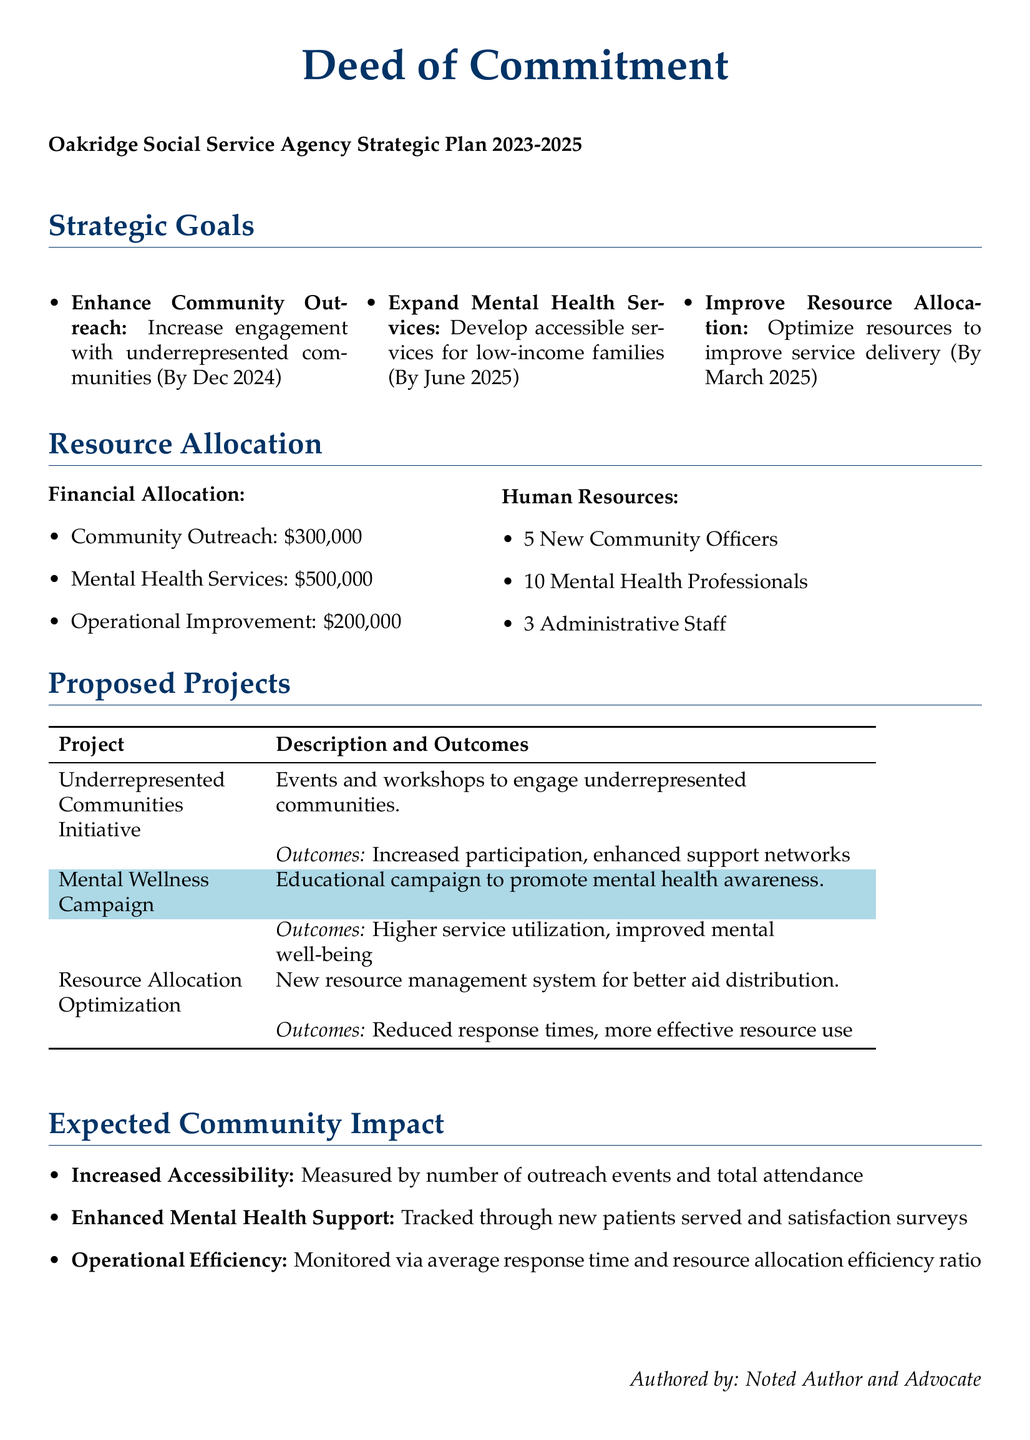What is the total financial allocation for Mental Health Services? The financial allocation for Mental Health Services is specifically stated in the document as $500,000.
Answer: $500,000 How many community officers are being hired? The document states that 5 new community officers will be hired, as indicated in the human resources section.
Answer: 5 What is the completion date for expanding mental health services? The document specifies that the goal to expand mental health services is set to be completed by June 2025.
Answer: June 2025 What is one outcome of the Underrepresented Communities Initiative? The document mentions that one outcome of the initiative is increased participation.
Answer: Increased participation What is the expected metric for measuring enhanced mental health support? The document indicates that new patients served is one of the metrics for measurement.
Answer: New patients served How much funding is allocated for Operational Improvement? The document clearly states that the funding allocated for Operational Improvement is $200,000.
Answer: $200,000 What is the goal related to resource allocation optimization completion date? The document notes that the goal of improving resource allocation is set for March 2025.
Answer: March 2025 What is a specific measure of operational efficiency mentioned? The document mentions that average response time is a specific measure of operational efficiency.
Answer: Average response time What is the main focus of the Mental Wellness Campaign? The document describes that the main focus of the campaign is to promote mental health awareness.
Answer: Promote mental health awareness 